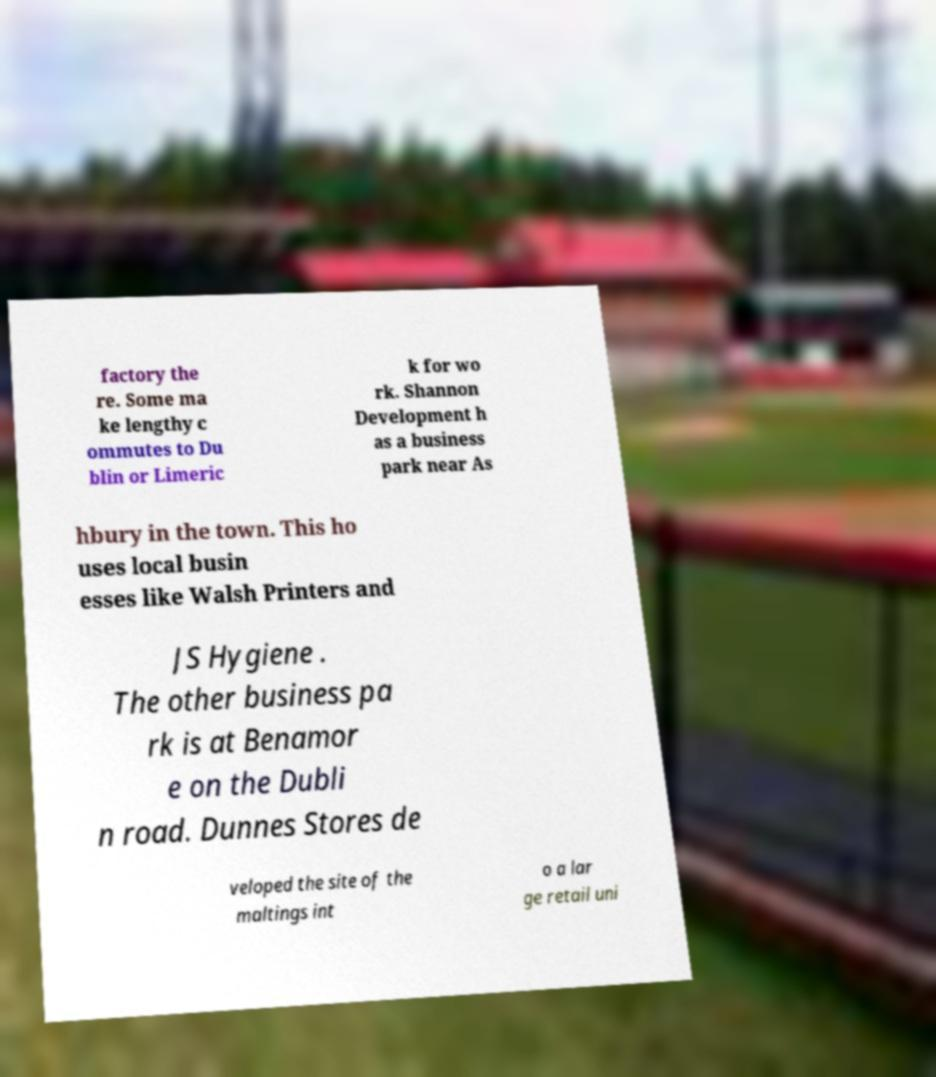Could you assist in decoding the text presented in this image and type it out clearly? factory the re. Some ma ke lengthy c ommutes to Du blin or Limeric k for wo rk. Shannon Development h as a business park near As hbury in the town. This ho uses local busin esses like Walsh Printers and JS Hygiene . The other business pa rk is at Benamor e on the Dubli n road. Dunnes Stores de veloped the site of the maltings int o a lar ge retail uni 